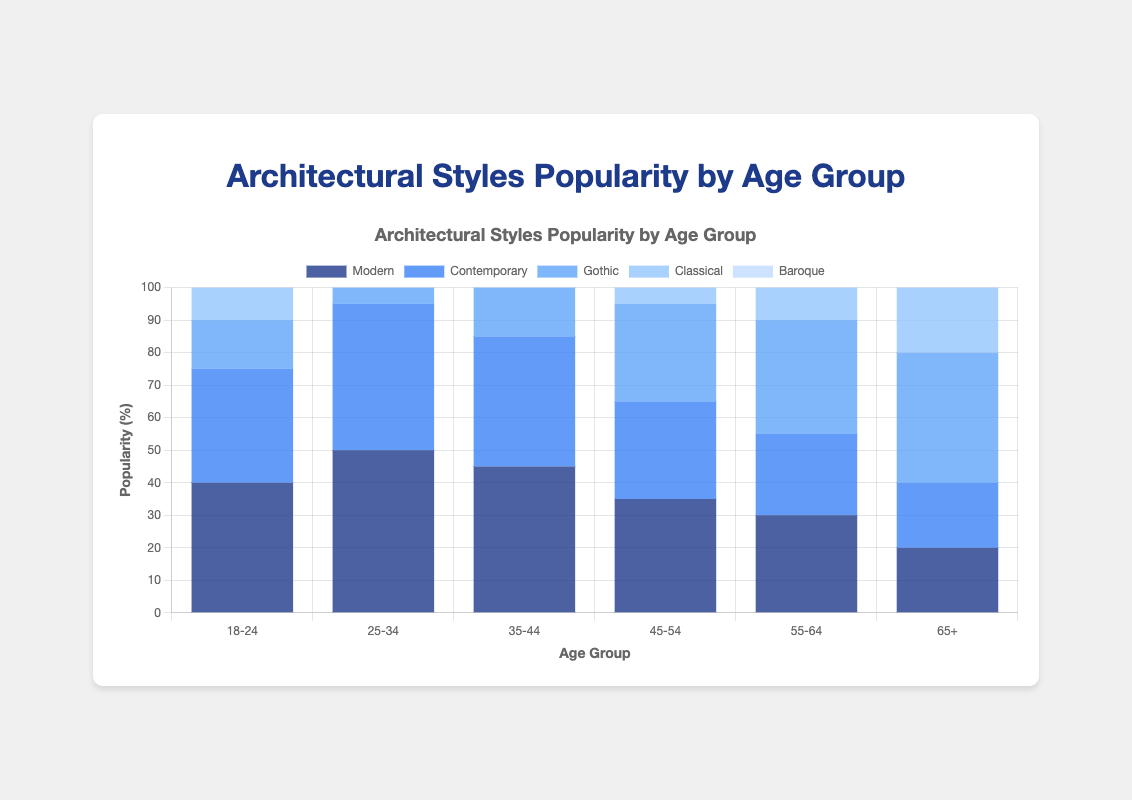What is the most popular architectural style among the 25-34 age group? The tallest bar in the 25-34 age group corresponds to the Modern style, represented by the dark blue color.
Answer: Modern Which age group has the highest preference for Classical architecture? The 65+ age group has the longest/lightest blue bar for the Classical style.
Answer: 65+ How many percentage points more popular is Gothic architecture in the 55-64 age group compared to the 18-24 age group? Gothic is 35% in the 55-64 group and 15% in the 18-24 group. So, 35% - 15% = 20%.
Answer: 20 Which architectural style sees a steady increase in popularity as age progresses from 18-24 to 65+? Classical style increases steadily: 25, 30, 35, 40, 45, 50.
Answer: Classical What is the combined popularity percentage of Modern and Contemporary architecture for the 35-44 age group? Modern is 45% and Contemporary is 40% in the 35-44 age group, so 45% + 40% = 85%.
Answer: 85 Which architectural style is equally popular among the age groups 55-64 and 65+? Contemporary shows the same popularity percentage (25%) for both age groups 55-64 and 65+.
Answer: Contemporary By how many percentage points is Contemporary more popular in the 25-34 age group compared to the 45-54 age group? Contemporary is 45% in the 25-34 group and 30% in the 45-54 group. So, 45% - 30% = 15%.
Answer: 15 Which age group shows an equally strong preference for both Modern and Contemporary architecture? The 18-24 age group shows 40% for Modern and 35% for Contemporary, but the closest match is the 65+ group with 20% for both.
Answer: 65+ 